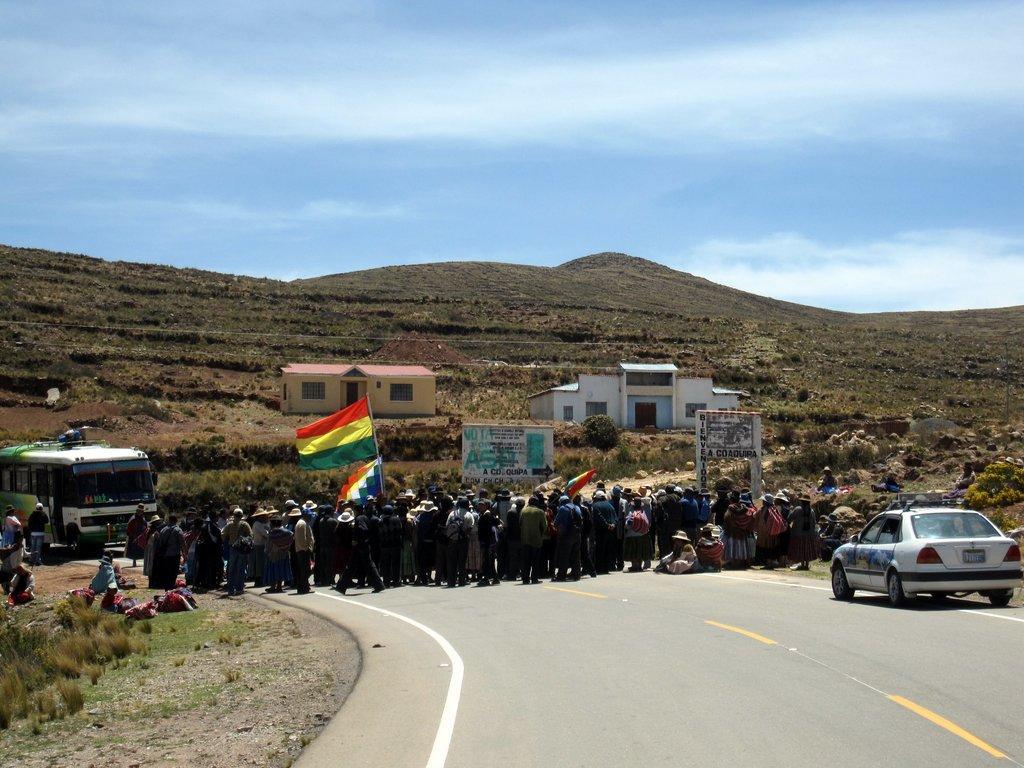Please provide a concise description of this image. In the foreground I can see a crowd, car and bus on the road. In the background I can see houses and mountains. On the top I can see the sky. This image is taken during a day. 